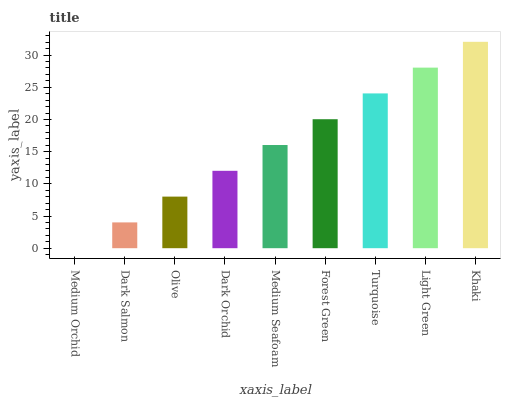Is Medium Orchid the minimum?
Answer yes or no. Yes. Is Khaki the maximum?
Answer yes or no. Yes. Is Dark Salmon the minimum?
Answer yes or no. No. Is Dark Salmon the maximum?
Answer yes or no. No. Is Dark Salmon greater than Medium Orchid?
Answer yes or no. Yes. Is Medium Orchid less than Dark Salmon?
Answer yes or no. Yes. Is Medium Orchid greater than Dark Salmon?
Answer yes or no. No. Is Dark Salmon less than Medium Orchid?
Answer yes or no. No. Is Medium Seafoam the high median?
Answer yes or no. Yes. Is Medium Seafoam the low median?
Answer yes or no. Yes. Is Light Green the high median?
Answer yes or no. No. Is Turquoise the low median?
Answer yes or no. No. 